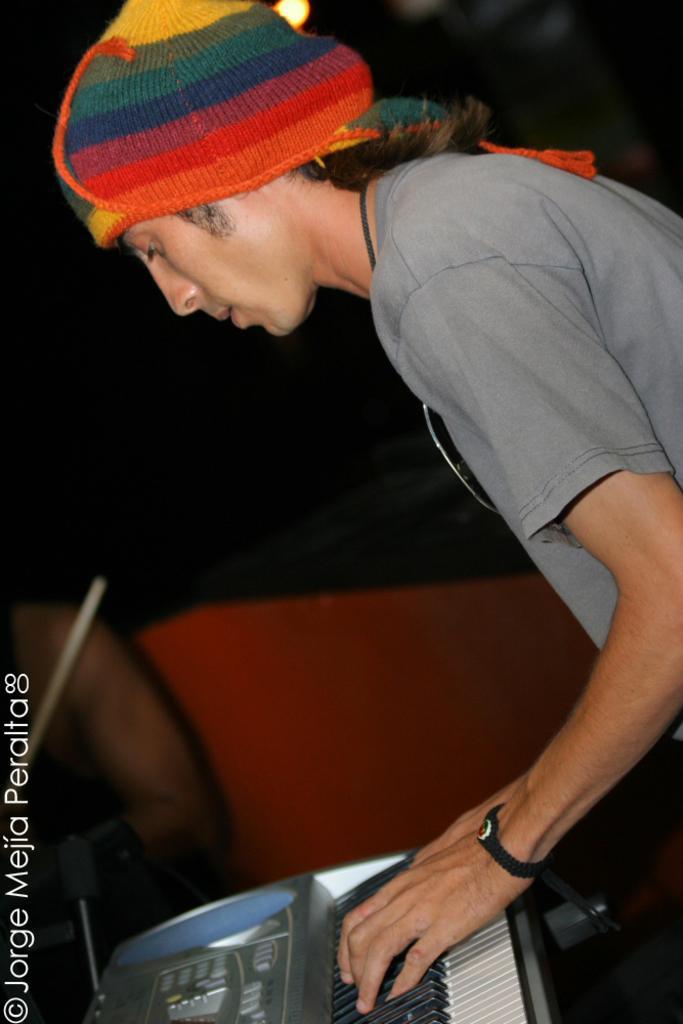Could you give a brief overview of what you see in this image? In the foreground of this image, on the right, there is a man standing and wearing a cap on his head and he is playing a keyboard. In the background, there is a man, a black and an orange background. 